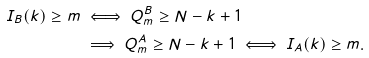<formula> <loc_0><loc_0><loc_500><loc_500>I _ { B } ( k ) \geq m & \iff Q _ { m } ^ { B } \geq N - k + 1 \\ & \implies Q _ { m } ^ { A } \geq N - k + 1 \iff I _ { A } ( k ) \geq m .</formula> 